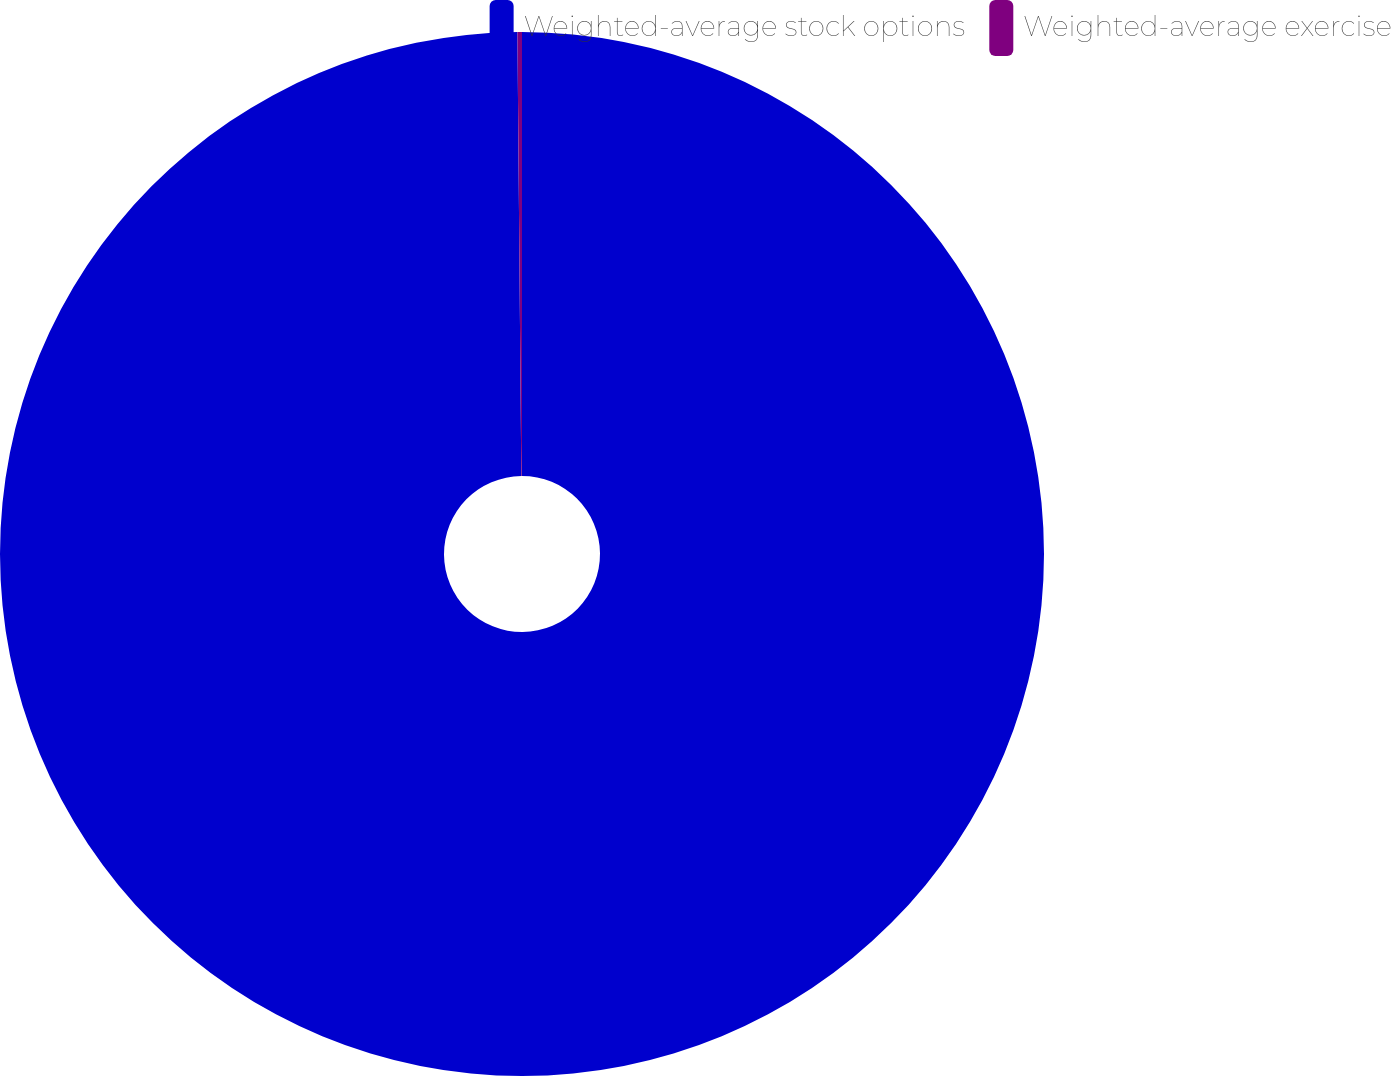<chart> <loc_0><loc_0><loc_500><loc_500><pie_chart><fcel>Weighted-average stock options<fcel>Weighted-average exercise<nl><fcel>99.86%<fcel>0.14%<nl></chart> 